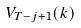<formula> <loc_0><loc_0><loc_500><loc_500>V _ { T - j + 1 } ( k )</formula> 